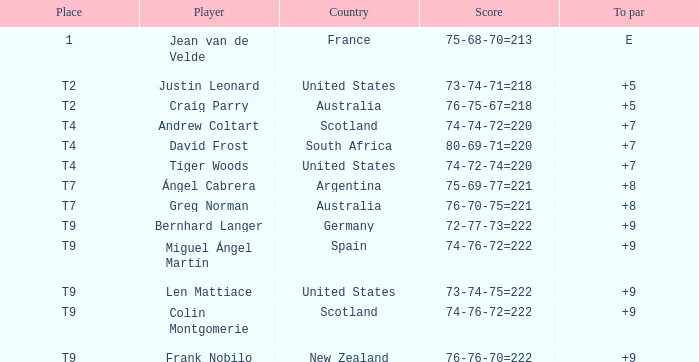Which player from the United States is in a place of T2? Justin Leonard. 